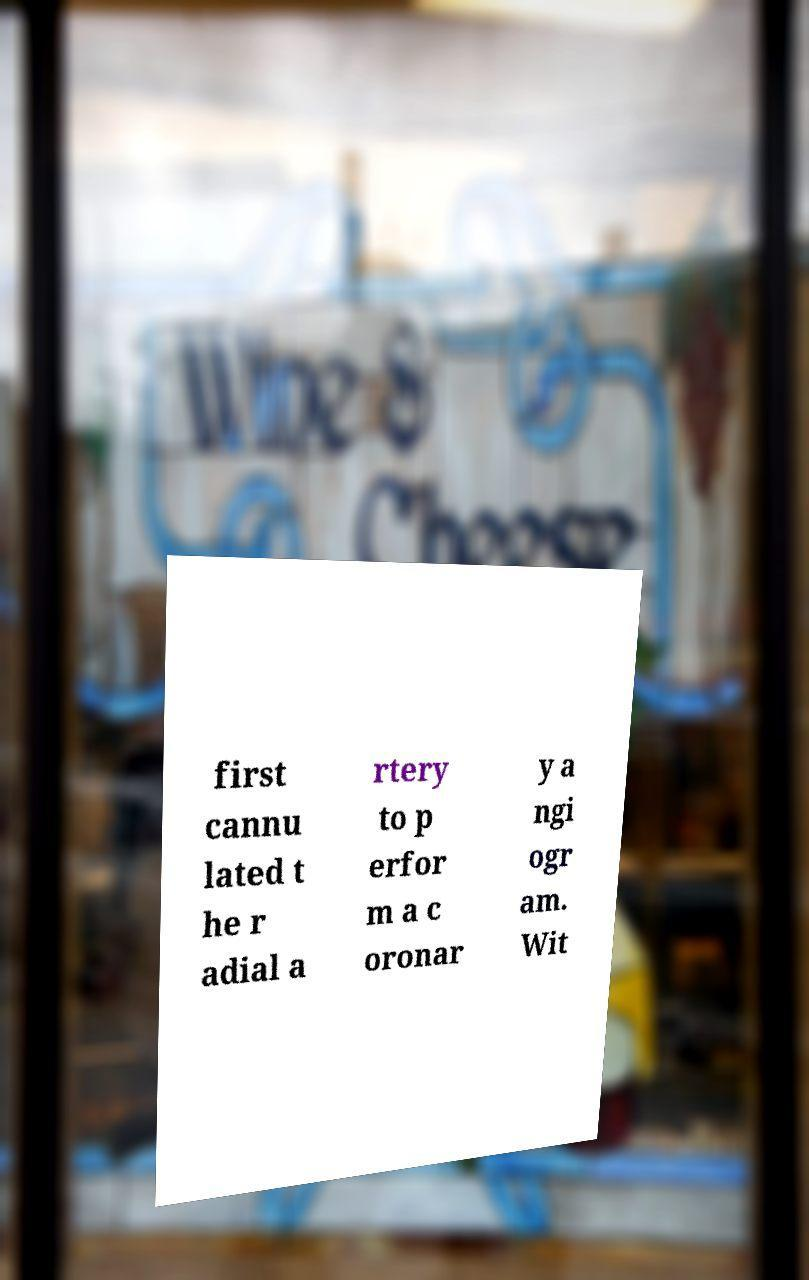Please identify and transcribe the text found in this image. first cannu lated t he r adial a rtery to p erfor m a c oronar y a ngi ogr am. Wit 